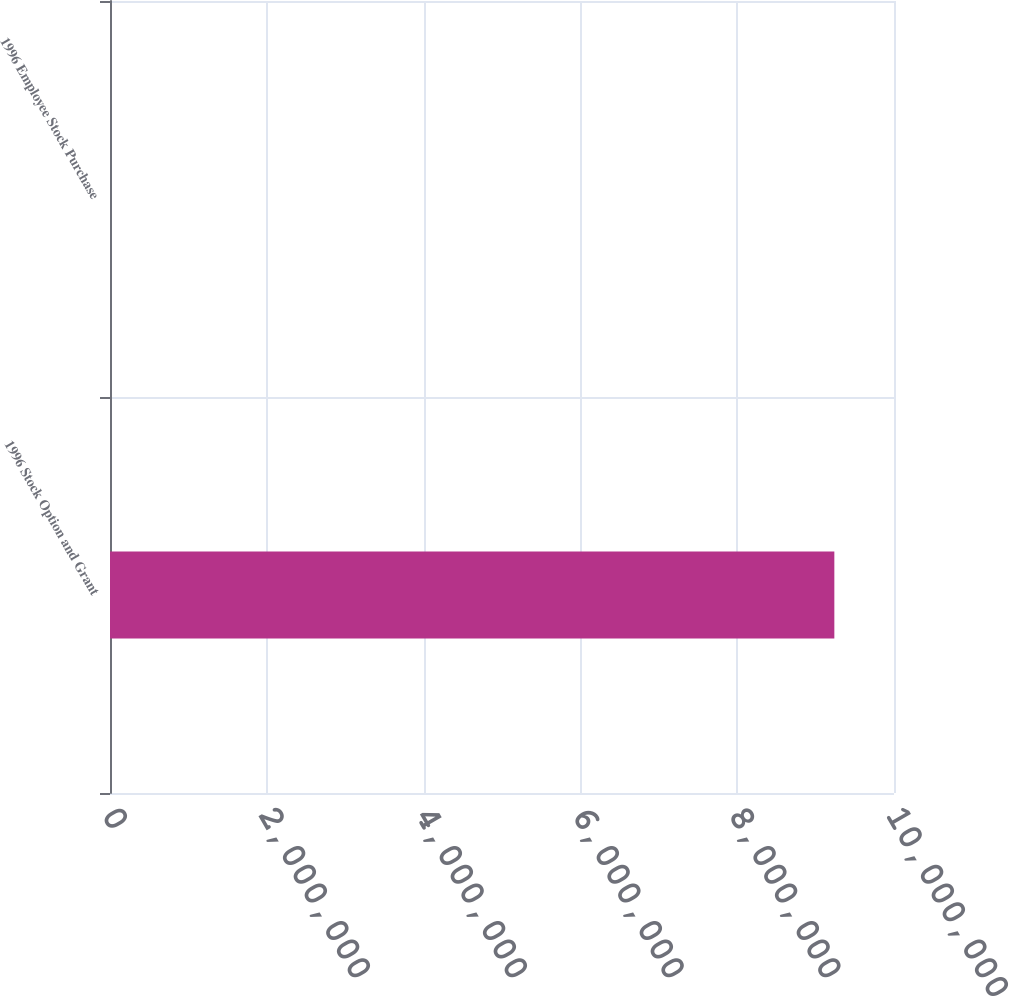<chart> <loc_0><loc_0><loc_500><loc_500><bar_chart><fcel>1996 Stock Option and Grant<fcel>1996 Employee Stock Purchase<nl><fcel>9.23908e+06<fcel>1<nl></chart> 